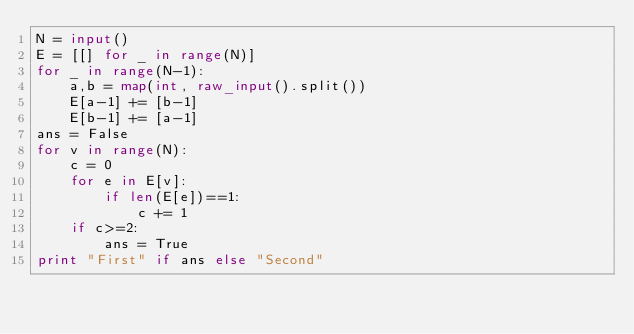<code> <loc_0><loc_0><loc_500><loc_500><_Python_>N = input()
E = [[] for _ in range(N)]
for _ in range(N-1):
    a,b = map(int, raw_input().split())
    E[a-1] += [b-1]
    E[b-1] += [a-1]
ans = False
for v in range(N):
    c = 0
    for e in E[v]:
        if len(E[e])==1:
            c += 1
    if c>=2:
        ans = True
print "First" if ans else "Second"
</code> 